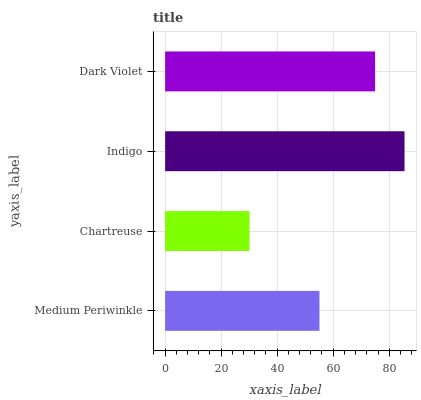Is Chartreuse the minimum?
Answer yes or no. Yes. Is Indigo the maximum?
Answer yes or no. Yes. Is Indigo the minimum?
Answer yes or no. No. Is Chartreuse the maximum?
Answer yes or no. No. Is Indigo greater than Chartreuse?
Answer yes or no. Yes. Is Chartreuse less than Indigo?
Answer yes or no. Yes. Is Chartreuse greater than Indigo?
Answer yes or no. No. Is Indigo less than Chartreuse?
Answer yes or no. No. Is Dark Violet the high median?
Answer yes or no. Yes. Is Medium Periwinkle the low median?
Answer yes or no. Yes. Is Indigo the high median?
Answer yes or no. No. Is Indigo the low median?
Answer yes or no. No. 